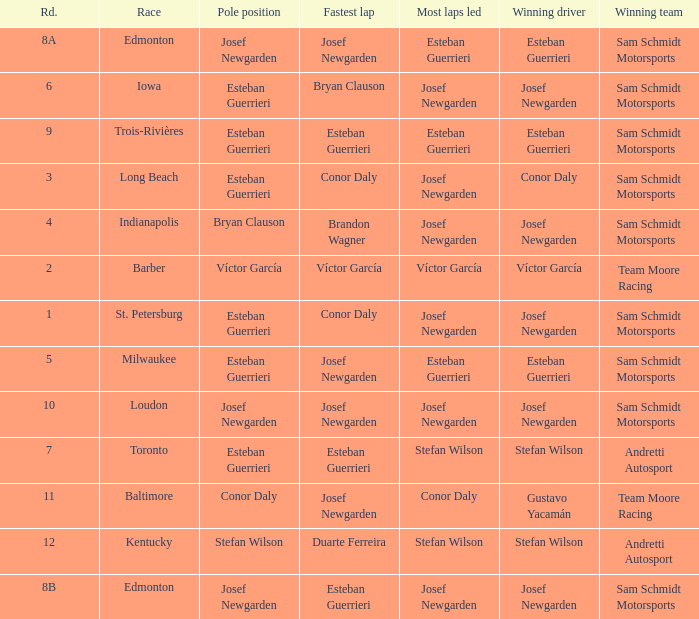Who had the pole(s) when esteban guerrieri led the most laps round 8a and josef newgarden had the fastest lap? Josef Newgarden. 